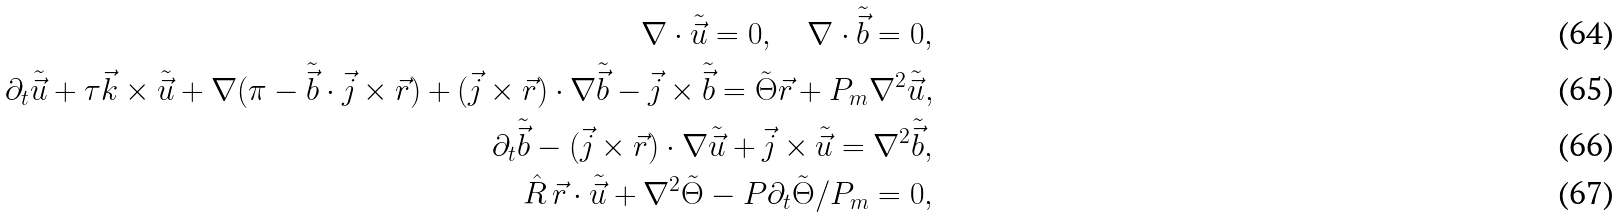Convert formula to latex. <formula><loc_0><loc_0><loc_500><loc_500>\nabla \cdot \tilde { \vec { u } } = 0 , \quad \nabla \cdot \tilde { \vec { b } } = 0 , \\ \partial _ { t } \tilde { \vec { u } } + \tau \vec { k } \times \tilde { \vec { u } } + \nabla ( \pi - \tilde { \vec { b } } \cdot \vec { j } \times \vec { r } ) + ( \vec { j } \times \vec { r } ) \cdot \nabla \tilde { \vec { b } } - \vec { j } \times \tilde { \vec { b } } = \tilde { \Theta } \vec { r } + P _ { m } \nabla ^ { 2 } \tilde { \vec { u } } , \\ \partial _ { t } \tilde { \vec { b } } - ( \vec { j } \times \vec { r } ) \cdot \nabla \tilde { \vec { u } } + \vec { j } \times \tilde { \vec { u } } = \nabla ^ { 2 } \tilde { \vec { b } } , \\ \hat { R } \, \vec { r } \cdot \tilde { \vec { u } } + \nabla ^ { 2 } \tilde { \Theta } - P \partial _ { t } \tilde { \Theta } / P _ { m } = 0 ,</formula> 